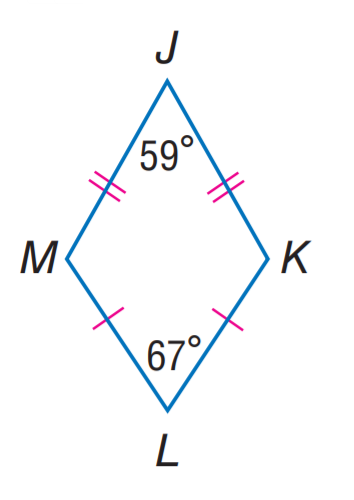Answer the mathemtical geometry problem and directly provide the correct option letter.
Question: Find m \angle K.
Choices: A: 105 B: 113 C: 117 D: 121 C 